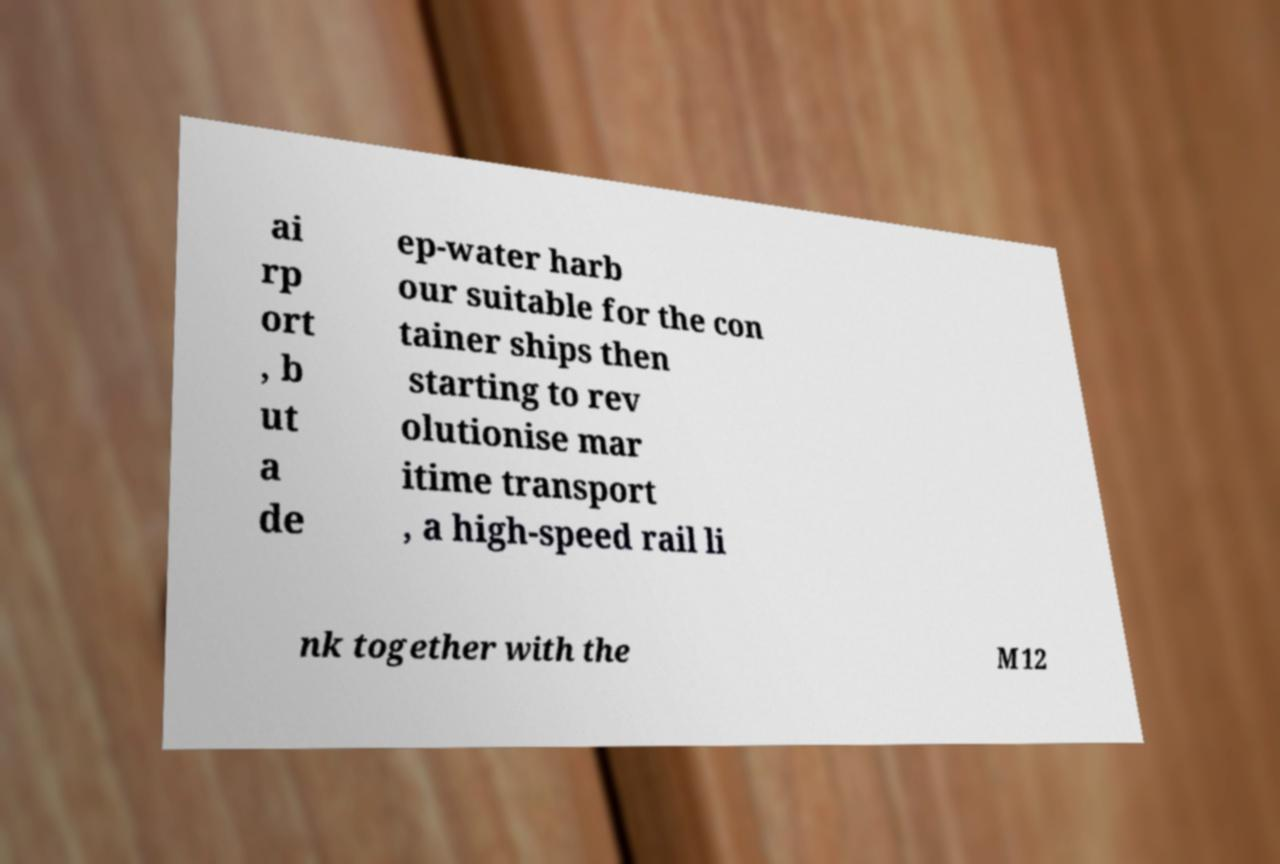What messages or text are displayed in this image? I need them in a readable, typed format. ai rp ort , b ut a de ep-water harb our suitable for the con tainer ships then starting to rev olutionise mar itime transport , a high-speed rail li nk together with the M12 